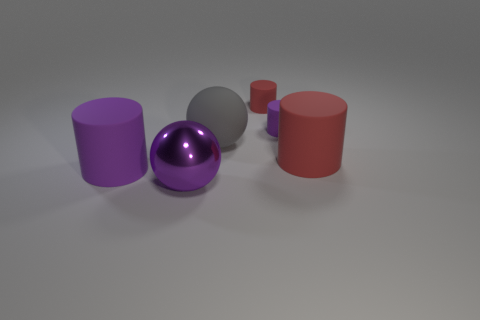Add 3 red objects. How many objects exist? 9 Subtract all spheres. How many objects are left? 4 Subtract all red things. Subtract all green objects. How many objects are left? 4 Add 4 gray matte balls. How many gray matte balls are left? 5 Add 2 gray rubber spheres. How many gray rubber spheres exist? 3 Subtract 0 purple blocks. How many objects are left? 6 